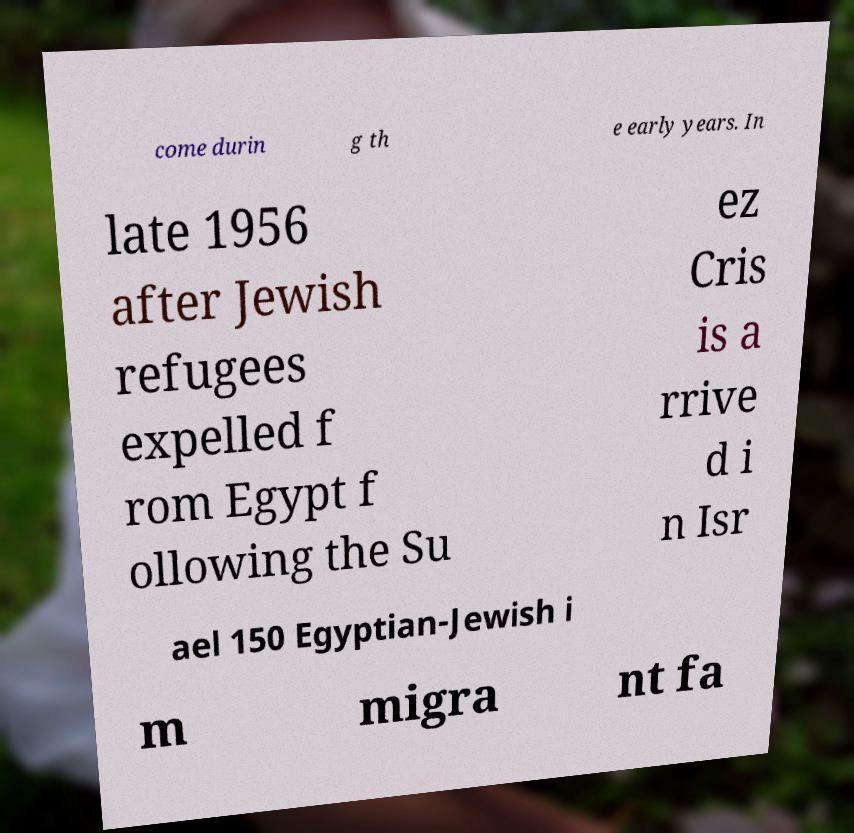Can you accurately transcribe the text from the provided image for me? come durin g th e early years. In late 1956 after Jewish refugees expelled f rom Egypt f ollowing the Su ez Cris is a rrive d i n Isr ael 150 Egyptian-Jewish i m migra nt fa 